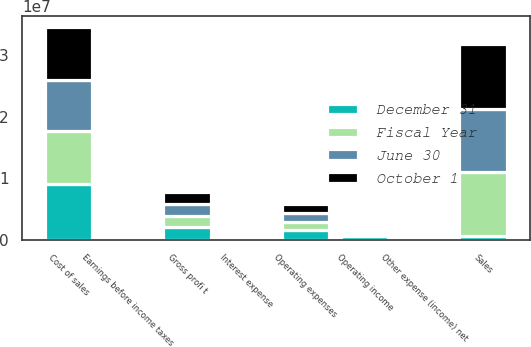Convert chart to OTSL. <chart><loc_0><loc_0><loc_500><loc_500><stacked_bar_chart><ecel><fcel>Sales<fcel>Cost of sales<fcel>Gross profi t<fcel>Operating expenses<fcel>Operating income<fcel>Interest expense<fcel>Other expense (income) net<fcel>Earnings before income taxes<nl><fcel>October 1<fcel>1.05864e+07<fcel>8.63879e+06<fcel>1.9476e+06<fcel>1.43826e+06<fcel>509340<fcel>29474<fcel>250<fcel>479616<nl><fcel>June 30<fcel>1.02444e+07<fcel>8.39877e+06<fcel>1.84565e+06<fcel>1.41865e+06<fcel>426998<fcel>28324<fcel>3472<fcel>402146<nl><fcel>Fiscal Year<fcel>1.05047e+07<fcel>8.63313e+06<fcel>1.87162e+06<fcel>1.43279e+06<fcel>438830<fcel>28290<fcel>2248<fcel>412788<nl><fcel>December 31<fcel>515464<fcel>9.03367e+06<fcel>2.01171e+06<fcel>1.49625e+06<fcel>515464<fcel>27308<fcel>1296<fcel>489452<nl></chart> 